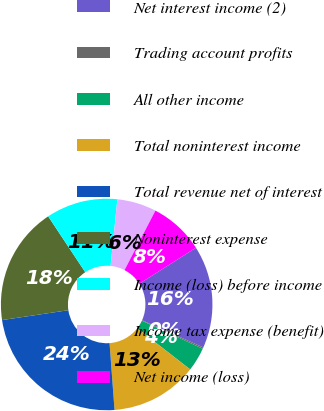<chart> <loc_0><loc_0><loc_500><loc_500><pie_chart><fcel>Net interest income (2)<fcel>Trading account profits<fcel>All other income<fcel>Total noninterest income<fcel>Total revenue net of interest<fcel>Noninterest expense<fcel>Income (loss) before income<fcel>Income tax expense (benefit)<fcel>Net income (loss)<nl><fcel>15.67%<fcel>0.21%<fcel>3.65%<fcel>13.3%<fcel>23.83%<fcel>18.03%<fcel>10.94%<fcel>6.01%<fcel>8.37%<nl></chart> 